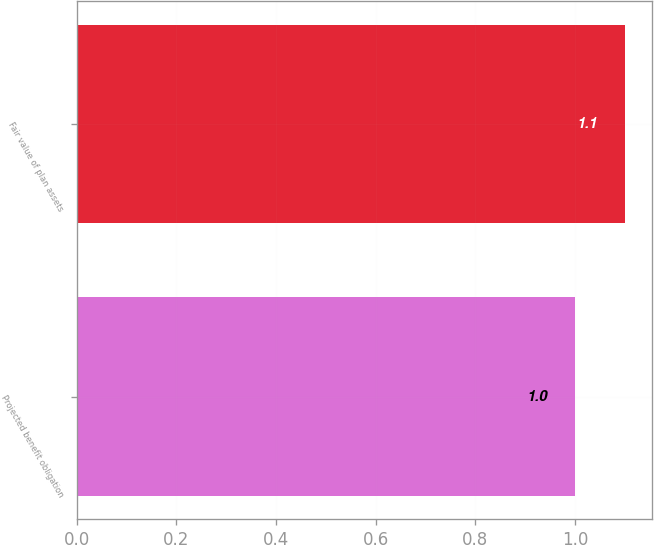Convert chart to OTSL. <chart><loc_0><loc_0><loc_500><loc_500><bar_chart><fcel>Projected benefit obligation<fcel>Fair value of plan assets<nl><fcel>1<fcel>1.1<nl></chart> 